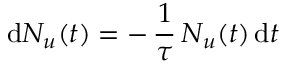<formula> <loc_0><loc_0><loc_500><loc_500>d { N } _ { u } ( t ) = - \, \frac { 1 } { \tau } \, N _ { u } ( t ) \, d t</formula> 